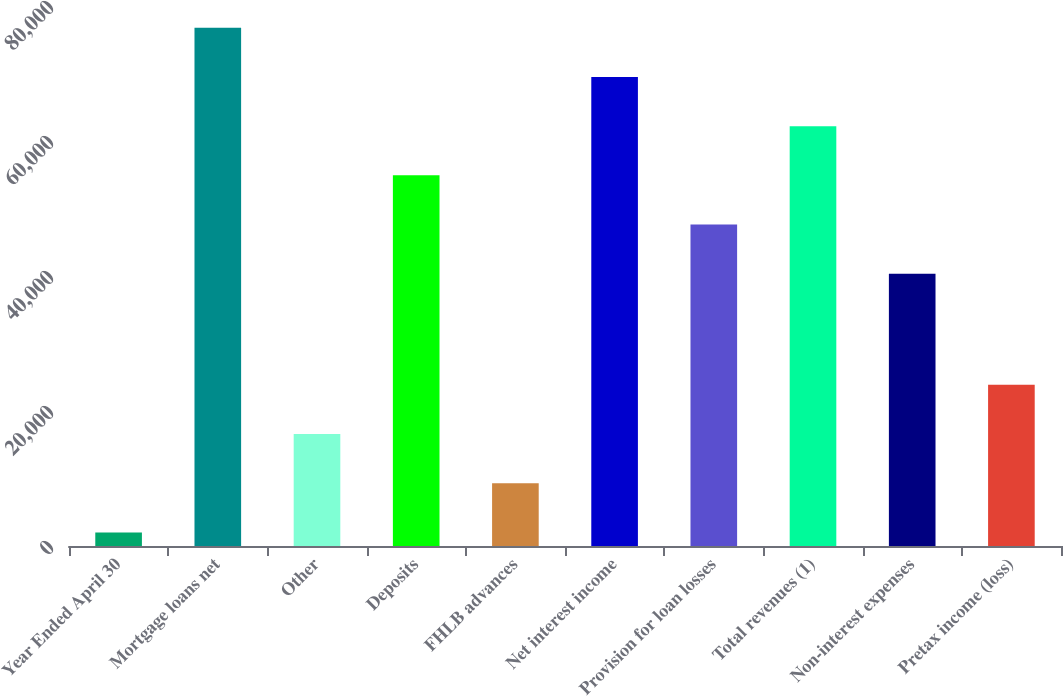Convert chart to OTSL. <chart><loc_0><loc_0><loc_500><loc_500><bar_chart><fcel>Year Ended April 30<fcel>Mortgage loans net<fcel>Other<fcel>Deposits<fcel>FHLB advances<fcel>Net interest income<fcel>Provision for loan losses<fcel>Total revenues (1)<fcel>Non-interest expenses<fcel>Pretax income (loss)<nl><fcel>2008<fcel>76775.5<fcel>16585.4<fcel>54909.4<fcel>9296.7<fcel>69486.8<fcel>47620.7<fcel>62198.1<fcel>40332<fcel>23874.1<nl></chart> 